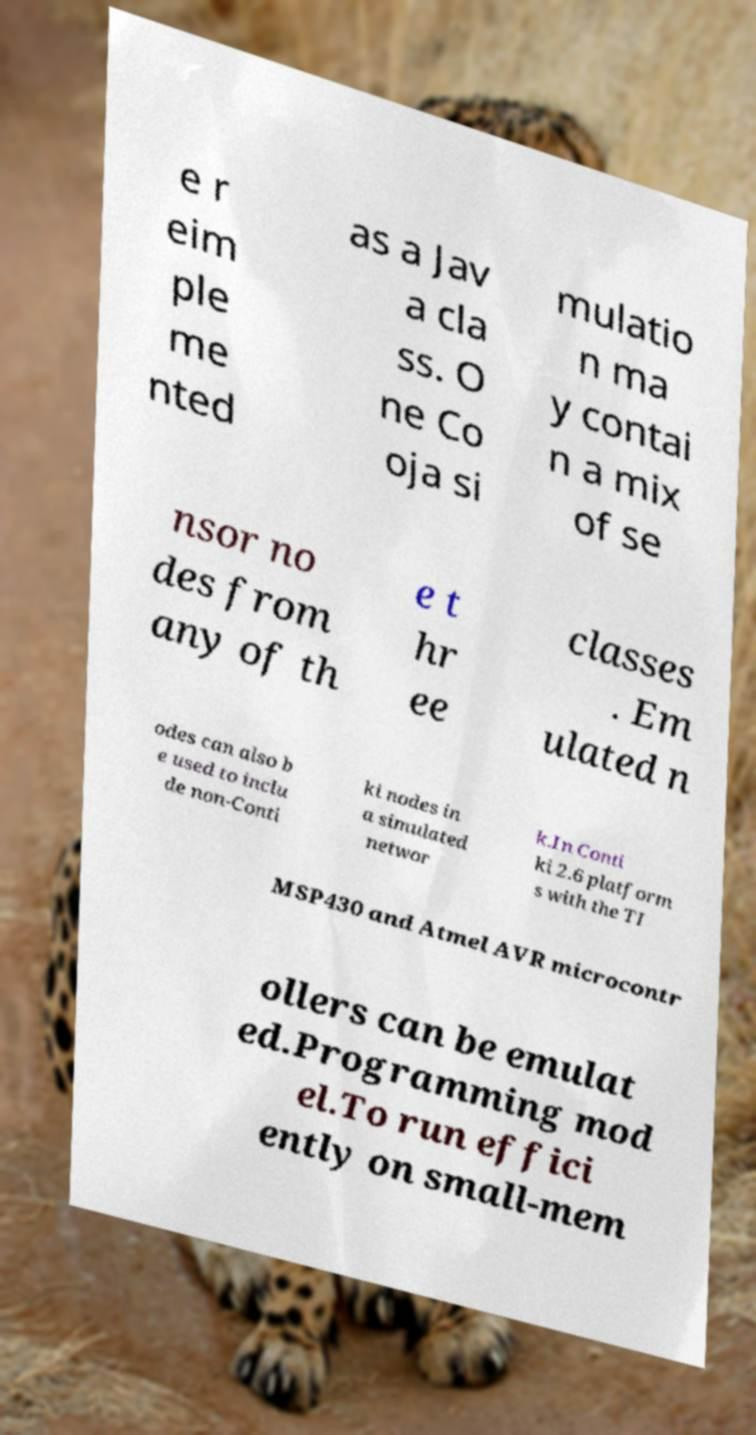Please read and relay the text visible in this image. What does it say? e r eim ple me nted as a Jav a cla ss. O ne Co oja si mulatio n ma y contai n a mix of se nsor no des from any of th e t hr ee classes . Em ulated n odes can also b e used to inclu de non-Conti ki nodes in a simulated networ k.In Conti ki 2.6 platform s with the TI MSP430 and Atmel AVR microcontr ollers can be emulat ed.Programming mod el.To run effici ently on small-mem 